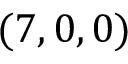Convert formula to latex. <formula><loc_0><loc_0><loc_500><loc_500>( 7 , 0 , 0 )</formula> 